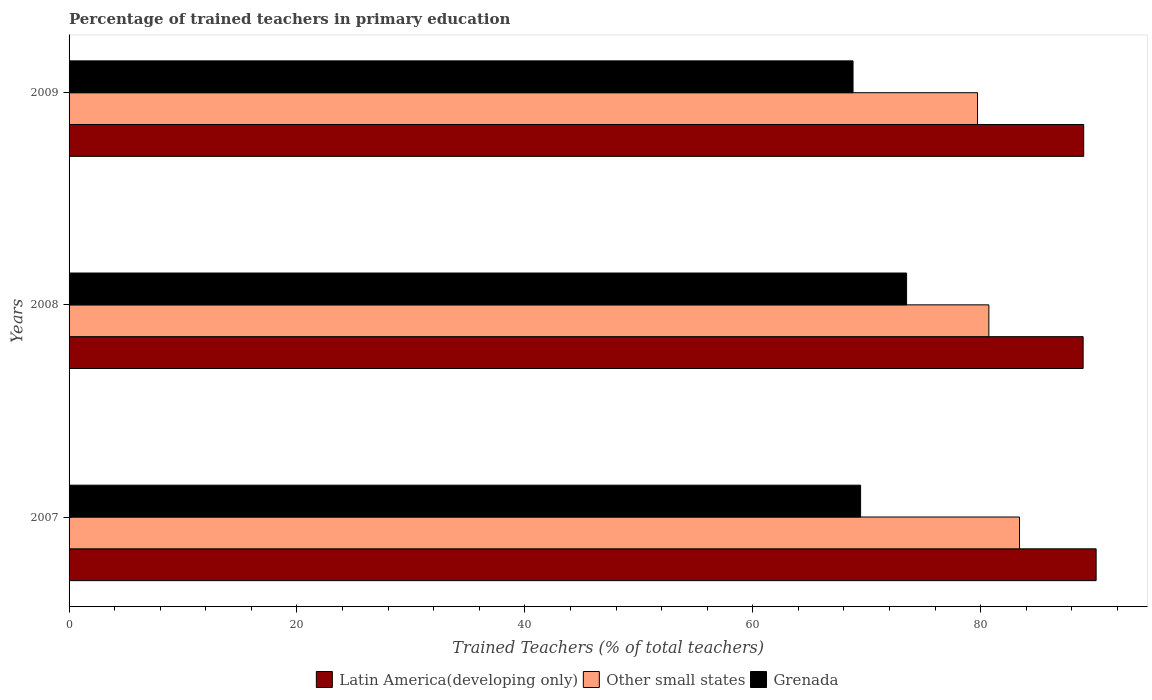How many groups of bars are there?
Your answer should be very brief. 3. How many bars are there on the 3rd tick from the top?
Ensure brevity in your answer.  3. In how many cases, is the number of bars for a given year not equal to the number of legend labels?
Your answer should be very brief. 0. What is the percentage of trained teachers in Grenada in 2009?
Your response must be concise. 68.8. Across all years, what is the maximum percentage of trained teachers in Grenada?
Provide a succinct answer. 73.5. Across all years, what is the minimum percentage of trained teachers in Grenada?
Provide a short and direct response. 68.8. In which year was the percentage of trained teachers in Other small states maximum?
Provide a short and direct response. 2007. In which year was the percentage of trained teachers in Grenada minimum?
Provide a short and direct response. 2009. What is the total percentage of trained teachers in Grenada in the graph?
Make the answer very short. 211.75. What is the difference between the percentage of trained teachers in Other small states in 2007 and that in 2008?
Give a very brief answer. 2.69. What is the difference between the percentage of trained teachers in Latin America(developing only) in 2009 and the percentage of trained teachers in Grenada in 2007?
Offer a terse response. 19.58. What is the average percentage of trained teachers in Latin America(developing only) per year?
Make the answer very short. 89.38. In the year 2007, what is the difference between the percentage of trained teachers in Latin America(developing only) and percentage of trained teachers in Grenada?
Provide a short and direct response. 20.67. What is the ratio of the percentage of trained teachers in Grenada in 2008 to that in 2009?
Provide a short and direct response. 1.07. Is the percentage of trained teachers in Latin America(developing only) in 2007 less than that in 2009?
Ensure brevity in your answer.  No. Is the difference between the percentage of trained teachers in Latin America(developing only) in 2007 and 2008 greater than the difference between the percentage of trained teachers in Grenada in 2007 and 2008?
Provide a succinct answer. Yes. What is the difference between the highest and the second highest percentage of trained teachers in Latin America(developing only)?
Give a very brief answer. 1.09. What is the difference between the highest and the lowest percentage of trained teachers in Latin America(developing only)?
Your answer should be compact. 1.14. What does the 1st bar from the top in 2007 represents?
Provide a succinct answer. Grenada. What does the 3rd bar from the bottom in 2008 represents?
Provide a succinct answer. Grenada. Does the graph contain grids?
Your answer should be compact. No. Where does the legend appear in the graph?
Keep it short and to the point. Bottom center. How are the legend labels stacked?
Offer a terse response. Horizontal. What is the title of the graph?
Offer a terse response. Percentage of trained teachers in primary education. Does "Tanzania" appear as one of the legend labels in the graph?
Give a very brief answer. No. What is the label or title of the X-axis?
Provide a succinct answer. Trained Teachers (% of total teachers). What is the Trained Teachers (% of total teachers) of Latin America(developing only) in 2007?
Your answer should be compact. 90.13. What is the Trained Teachers (% of total teachers) in Other small states in 2007?
Make the answer very short. 83.4. What is the Trained Teachers (% of total teachers) of Grenada in 2007?
Your answer should be very brief. 69.46. What is the Trained Teachers (% of total teachers) of Latin America(developing only) in 2008?
Offer a very short reply. 88.99. What is the Trained Teachers (% of total teachers) in Other small states in 2008?
Offer a very short reply. 80.71. What is the Trained Teachers (% of total teachers) in Grenada in 2008?
Keep it short and to the point. 73.5. What is the Trained Teachers (% of total teachers) in Latin America(developing only) in 2009?
Your answer should be compact. 89.04. What is the Trained Teachers (% of total teachers) in Other small states in 2009?
Make the answer very short. 79.72. What is the Trained Teachers (% of total teachers) of Grenada in 2009?
Your response must be concise. 68.8. Across all years, what is the maximum Trained Teachers (% of total teachers) of Latin America(developing only)?
Offer a terse response. 90.13. Across all years, what is the maximum Trained Teachers (% of total teachers) of Other small states?
Ensure brevity in your answer.  83.4. Across all years, what is the maximum Trained Teachers (% of total teachers) of Grenada?
Keep it short and to the point. 73.5. Across all years, what is the minimum Trained Teachers (% of total teachers) of Latin America(developing only)?
Keep it short and to the point. 88.99. Across all years, what is the minimum Trained Teachers (% of total teachers) of Other small states?
Your answer should be very brief. 79.72. Across all years, what is the minimum Trained Teachers (% of total teachers) of Grenada?
Offer a terse response. 68.8. What is the total Trained Teachers (% of total teachers) of Latin America(developing only) in the graph?
Keep it short and to the point. 268.15. What is the total Trained Teachers (% of total teachers) in Other small states in the graph?
Your response must be concise. 243.84. What is the total Trained Teachers (% of total teachers) in Grenada in the graph?
Provide a succinct answer. 211.75. What is the difference between the Trained Teachers (% of total teachers) in Latin America(developing only) in 2007 and that in 2008?
Your response must be concise. 1.14. What is the difference between the Trained Teachers (% of total teachers) in Other small states in 2007 and that in 2008?
Offer a terse response. 2.69. What is the difference between the Trained Teachers (% of total teachers) in Grenada in 2007 and that in 2008?
Your response must be concise. -4.04. What is the difference between the Trained Teachers (% of total teachers) of Latin America(developing only) in 2007 and that in 2009?
Offer a very short reply. 1.09. What is the difference between the Trained Teachers (% of total teachers) of Other small states in 2007 and that in 2009?
Your answer should be compact. 3.68. What is the difference between the Trained Teachers (% of total teachers) of Grenada in 2007 and that in 2009?
Offer a terse response. 0.67. What is the difference between the Trained Teachers (% of total teachers) of Latin America(developing only) in 2008 and that in 2009?
Make the answer very short. -0.05. What is the difference between the Trained Teachers (% of total teachers) of Other small states in 2008 and that in 2009?
Provide a succinct answer. 0.99. What is the difference between the Trained Teachers (% of total teachers) of Grenada in 2008 and that in 2009?
Offer a very short reply. 4.7. What is the difference between the Trained Teachers (% of total teachers) of Latin America(developing only) in 2007 and the Trained Teachers (% of total teachers) of Other small states in 2008?
Keep it short and to the point. 9.41. What is the difference between the Trained Teachers (% of total teachers) of Latin America(developing only) in 2007 and the Trained Teachers (% of total teachers) of Grenada in 2008?
Your answer should be very brief. 16.63. What is the difference between the Trained Teachers (% of total teachers) in Other small states in 2007 and the Trained Teachers (% of total teachers) in Grenada in 2008?
Give a very brief answer. 9.91. What is the difference between the Trained Teachers (% of total teachers) of Latin America(developing only) in 2007 and the Trained Teachers (% of total teachers) of Other small states in 2009?
Offer a very short reply. 10.41. What is the difference between the Trained Teachers (% of total teachers) in Latin America(developing only) in 2007 and the Trained Teachers (% of total teachers) in Grenada in 2009?
Make the answer very short. 21.33. What is the difference between the Trained Teachers (% of total teachers) of Other small states in 2007 and the Trained Teachers (% of total teachers) of Grenada in 2009?
Make the answer very short. 14.61. What is the difference between the Trained Teachers (% of total teachers) in Latin America(developing only) in 2008 and the Trained Teachers (% of total teachers) in Other small states in 2009?
Your response must be concise. 9.27. What is the difference between the Trained Teachers (% of total teachers) of Latin America(developing only) in 2008 and the Trained Teachers (% of total teachers) of Grenada in 2009?
Ensure brevity in your answer.  20.19. What is the difference between the Trained Teachers (% of total teachers) of Other small states in 2008 and the Trained Teachers (% of total teachers) of Grenada in 2009?
Your answer should be compact. 11.92. What is the average Trained Teachers (% of total teachers) of Latin America(developing only) per year?
Ensure brevity in your answer.  89.39. What is the average Trained Teachers (% of total teachers) of Other small states per year?
Offer a terse response. 81.28. What is the average Trained Teachers (% of total teachers) in Grenada per year?
Offer a very short reply. 70.58. In the year 2007, what is the difference between the Trained Teachers (% of total teachers) of Latin America(developing only) and Trained Teachers (% of total teachers) of Other small states?
Your response must be concise. 6.72. In the year 2007, what is the difference between the Trained Teachers (% of total teachers) in Latin America(developing only) and Trained Teachers (% of total teachers) in Grenada?
Your answer should be compact. 20.67. In the year 2007, what is the difference between the Trained Teachers (% of total teachers) in Other small states and Trained Teachers (% of total teachers) in Grenada?
Give a very brief answer. 13.94. In the year 2008, what is the difference between the Trained Teachers (% of total teachers) in Latin America(developing only) and Trained Teachers (% of total teachers) in Other small states?
Your answer should be very brief. 8.27. In the year 2008, what is the difference between the Trained Teachers (% of total teachers) in Latin America(developing only) and Trained Teachers (% of total teachers) in Grenada?
Offer a very short reply. 15.49. In the year 2008, what is the difference between the Trained Teachers (% of total teachers) of Other small states and Trained Teachers (% of total teachers) of Grenada?
Your answer should be compact. 7.22. In the year 2009, what is the difference between the Trained Teachers (% of total teachers) of Latin America(developing only) and Trained Teachers (% of total teachers) of Other small states?
Give a very brief answer. 9.32. In the year 2009, what is the difference between the Trained Teachers (% of total teachers) in Latin America(developing only) and Trained Teachers (% of total teachers) in Grenada?
Offer a terse response. 20.24. In the year 2009, what is the difference between the Trained Teachers (% of total teachers) in Other small states and Trained Teachers (% of total teachers) in Grenada?
Your answer should be very brief. 10.93. What is the ratio of the Trained Teachers (% of total teachers) of Latin America(developing only) in 2007 to that in 2008?
Your answer should be compact. 1.01. What is the ratio of the Trained Teachers (% of total teachers) of Grenada in 2007 to that in 2008?
Provide a short and direct response. 0.95. What is the ratio of the Trained Teachers (% of total teachers) in Latin America(developing only) in 2007 to that in 2009?
Offer a very short reply. 1.01. What is the ratio of the Trained Teachers (% of total teachers) in Other small states in 2007 to that in 2009?
Ensure brevity in your answer.  1.05. What is the ratio of the Trained Teachers (% of total teachers) of Grenada in 2007 to that in 2009?
Your response must be concise. 1.01. What is the ratio of the Trained Teachers (% of total teachers) of Latin America(developing only) in 2008 to that in 2009?
Give a very brief answer. 1. What is the ratio of the Trained Teachers (% of total teachers) of Other small states in 2008 to that in 2009?
Provide a short and direct response. 1.01. What is the ratio of the Trained Teachers (% of total teachers) in Grenada in 2008 to that in 2009?
Your answer should be compact. 1.07. What is the difference between the highest and the second highest Trained Teachers (% of total teachers) in Latin America(developing only)?
Give a very brief answer. 1.09. What is the difference between the highest and the second highest Trained Teachers (% of total teachers) in Other small states?
Give a very brief answer. 2.69. What is the difference between the highest and the second highest Trained Teachers (% of total teachers) of Grenada?
Give a very brief answer. 4.04. What is the difference between the highest and the lowest Trained Teachers (% of total teachers) in Latin America(developing only)?
Give a very brief answer. 1.14. What is the difference between the highest and the lowest Trained Teachers (% of total teachers) in Other small states?
Offer a very short reply. 3.68. What is the difference between the highest and the lowest Trained Teachers (% of total teachers) in Grenada?
Your answer should be very brief. 4.7. 